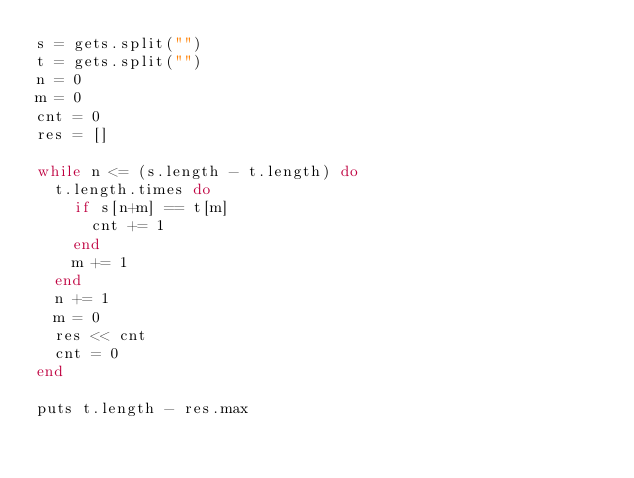Convert code to text. <code><loc_0><loc_0><loc_500><loc_500><_Ruby_>s = gets.split("")
t = gets.split("")
n = 0
m = 0
cnt = 0
res = []

while n <= (s.length - t.length) do
  t.length.times do
    if s[n+m] == t[m]
      cnt += 1
    end
    m += 1
  end
  n += 1
  m = 0
  res << cnt
  cnt = 0
end

puts t.length - res.max
</code> 